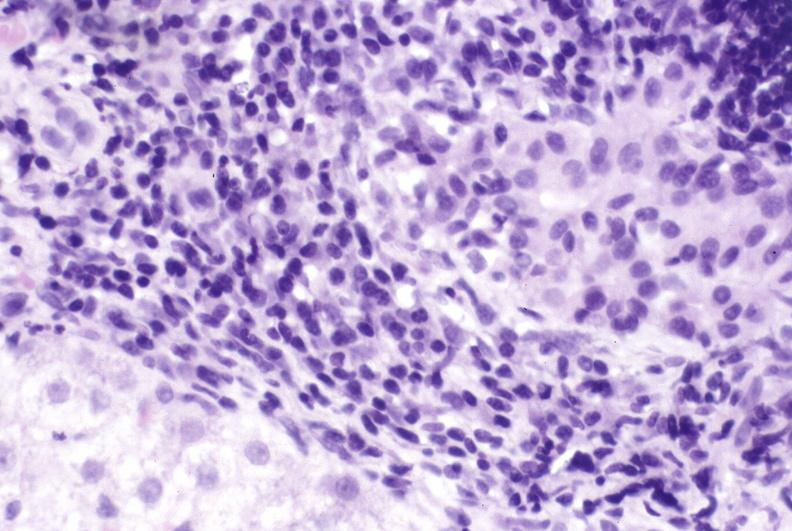s hepatobiliary present?
Answer the question using a single word or phrase. Yes 